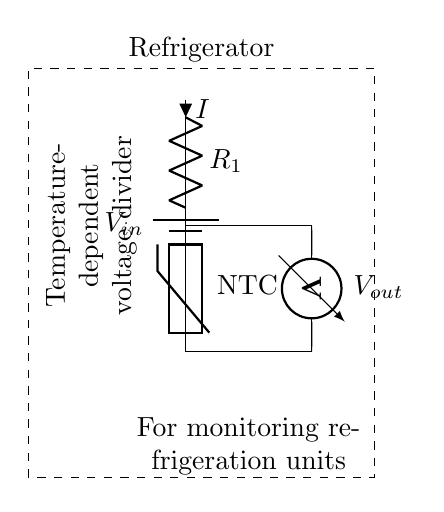What is the input voltage labeled in the circuit? The input voltage is labeled as *V_in* at the top of the circuit diagram, indicating where the voltage is supplied.
Answer: V_in What component is used to measure the output voltage? The component for measuring output voltage is a voltmeter, indicated by its label and connection at the output of the circuit.
Answer: Voltmeter What type of resistor is shown in the diagram? The diagram displays a thermistor, specifically an NTC (Negative Temperature Coefficient) thermistor, which changes resistance with temperature.
Answer: NTC thermistor What happens to the voltage output when the temperature increases? As the temperature increases, the resistance of the NTC thermistor decreases, leading to a higher voltage output across it due to the voltage divider principle.
Answer: Increases What is the role of the resistor labeled R1 in this circuit? Resistor R1 plays a crucial role in the voltage divider configuration, providing a reference point and working in conjunction with the thermistor to establish output voltage based on temperature changes.
Answer: Reference voltage What does the dashed rectangle enclosing the circuit represent? The dashed rectangle signifies the physical boundaries of the refrigerator system that the circuit is monitoring, emphasizing its application in refrigeration units.
Answer: Refrigerator What type of circuit configuration is implemented here? The circuit is configured as a voltage divider, which divides the input voltage into smaller voltages based on the resistances of R1 and the thermistor.
Answer: Voltage divider 